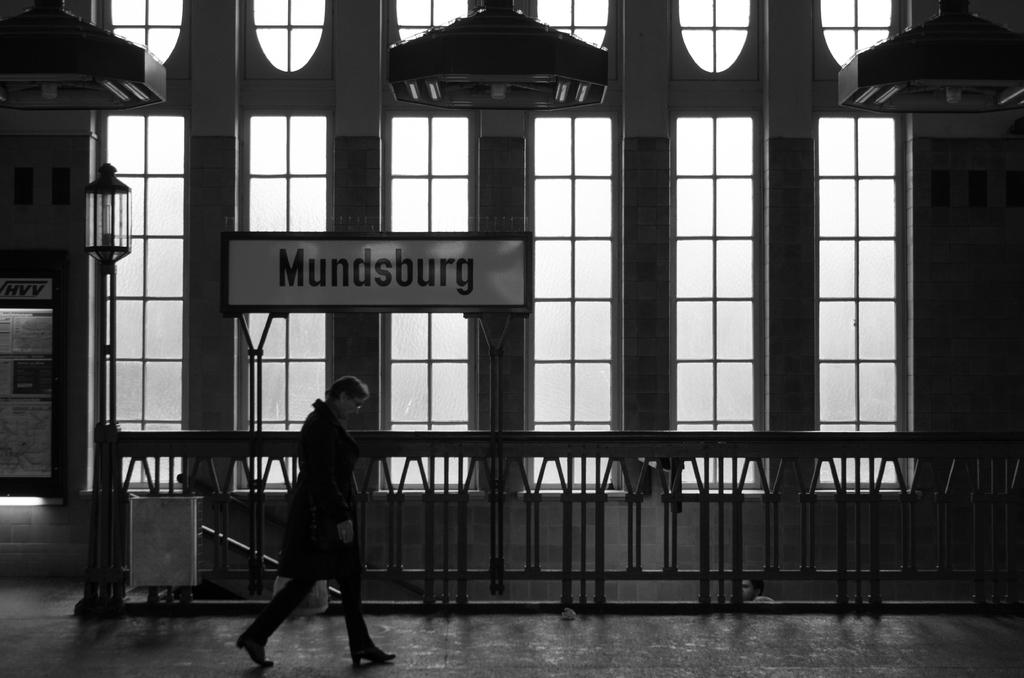Who or what is present in the image? There are people in the image. What can be seen in the background of the image? There are metal rods, lights, and a hoarding in the background of the image. What is the color scheme of the image? The image is in black and white. What type of button is being pushed by the people in the image? There is no button present in the image; it is a black and white image of people with metal rods, lights, and a hoarding in the background. How does the friction between the metal rods and the ground affect the people in the image? There is no information about friction or the interaction between the metal rods and the ground in the image. The image only shows people, metal rods, lights, and a hoarding in the background. 